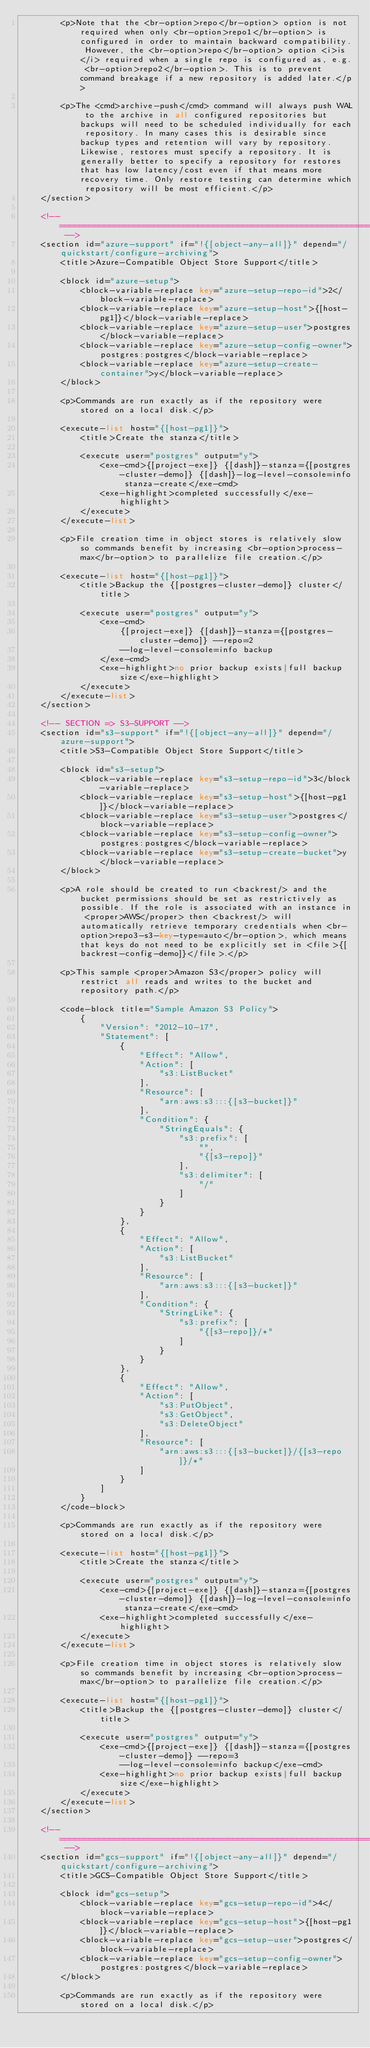Convert code to text. <code><loc_0><loc_0><loc_500><loc_500><_XML_>        <p>Note that the <br-option>repo</br-option> option is not required when only <br-option>repo1</br-option> is configured in order to maintain backward compatibility. However, the <br-option>repo</br-option> option <i>is</i> required when a single repo is configured as, e.g. <br-option>repo2</br-option>. This is to prevent command breakage if a new repository is added later.</p>

        <p>The <cmd>archive-push</cmd> command will always push WAL to the archive in all configured repositories but backups will need to be scheduled individually for each repository. In many cases this is desirable since backup types and retention will vary by repository. Likewise, restores must specify a repository. It is generally better to specify a repository for restores that has low latency/cost even if that means more recovery time. Only restore testing can determine which repository will be most efficient.</p>
    </section>

    <!-- ======================================================================================================================= -->
    <section id="azure-support" if="!{[object-any-all]}" depend="/quickstart/configure-archiving">
        <title>Azure-Compatible Object Store Support</title>

        <block id="azure-setup">
            <block-variable-replace key="azure-setup-repo-id">2</block-variable-replace>
            <block-variable-replace key="azure-setup-host">{[host-pg1]}</block-variable-replace>
            <block-variable-replace key="azure-setup-user">postgres</block-variable-replace>
            <block-variable-replace key="azure-setup-config-owner">postgres:postgres</block-variable-replace>
            <block-variable-replace key="azure-setup-create-container">y</block-variable-replace>
        </block>

        <p>Commands are run exactly as if the repository were stored on a local disk.</p>

        <execute-list host="{[host-pg1]}">
            <title>Create the stanza</title>

            <execute user="postgres" output="y">
                <exe-cmd>{[project-exe]} {[dash]}-stanza={[postgres-cluster-demo]} {[dash]}-log-level-console=info stanza-create</exe-cmd>
                <exe-highlight>completed successfully</exe-highlight>
            </execute>
        </execute-list>

        <p>File creation time in object stores is relatively slow so commands benefit by increasing <br-option>process-max</br-option> to parallelize file creation.</p>

        <execute-list host="{[host-pg1]}">
            <title>Backup the {[postgres-cluster-demo]} cluster</title>

            <execute user="postgres" output="y">
                <exe-cmd>
                    {[project-exe]} {[dash]}-stanza={[postgres-cluster-demo]} --repo=2
                    --log-level-console=info backup
                </exe-cmd>
                <exe-highlight>no prior backup exists|full backup size</exe-highlight>
            </execute>
        </execute-list>
    </section>

    <!-- SECTION => S3-SUPPORT -->
    <section id="s3-support" if="!{[object-any-all]}" depend="/azure-support">
        <title>S3-Compatible Object Store Support</title>

        <block id="s3-setup">
            <block-variable-replace key="s3-setup-repo-id">3</block-variable-replace>
            <block-variable-replace key="s3-setup-host">{[host-pg1]}</block-variable-replace>
            <block-variable-replace key="s3-setup-user">postgres</block-variable-replace>
            <block-variable-replace key="s3-setup-config-owner">postgres:postgres</block-variable-replace>
            <block-variable-replace key="s3-setup-create-bucket">y</block-variable-replace>
        </block>

        <p>A role should be created to run <backrest/> and the bucket permissions should be set as restrictively as possible. If the role is associated with an instance in <proper>AWS</proper> then <backrest/> will automatically retrieve temporary credentials when <br-option>repo3-s3-key-type=auto</br-option>, which means that keys do not need to be explicitly set in <file>{[backrest-config-demo]}</file>.</p>

        <p>This sample <proper>Amazon S3</proper> policy will restrict all reads and writes to the bucket and repository path.</p>

        <code-block title="Sample Amazon S3 Policy">
            {
                "Version": "2012-10-17",
                "Statement": [
                    {
                        "Effect": "Allow",
                        "Action": [
                            "s3:ListBucket"
                        ],
                        "Resource": [
                            "arn:aws:s3:::{[s3-bucket]}"
                        ],
                        "Condition": {
                            "StringEquals": {
                                "s3:prefix": [
                                    "",
                                    "{[s3-repo]}"
                                ],
                                "s3:delimiter": [
                                    "/"
                                ]
                            }
                        }
                    },
                    {
                        "Effect": "Allow",
                        "Action": [
                            "s3:ListBucket"
                        ],
                        "Resource": [
                            "arn:aws:s3:::{[s3-bucket]}"
                        ],
                        "Condition": {
                            "StringLike": {
                                "s3:prefix": [
                                    "{[s3-repo]}/*"
                                ]
                            }
                        }
                    },
                    {
                        "Effect": "Allow",
                        "Action": [
                            "s3:PutObject",
                            "s3:GetObject",
                            "s3:DeleteObject"
                        ],
                        "Resource": [
                            "arn:aws:s3:::{[s3-bucket]}/{[s3-repo]}/*"
                        ]
                    }
                ]
            }
        </code-block>

        <p>Commands are run exactly as if the repository were stored on a local disk.</p>

        <execute-list host="{[host-pg1]}">
            <title>Create the stanza</title>

            <execute user="postgres" output="y">
                <exe-cmd>{[project-exe]} {[dash]}-stanza={[postgres-cluster-demo]} {[dash]}-log-level-console=info stanza-create</exe-cmd>
                <exe-highlight>completed successfully</exe-highlight>
            </execute>
        </execute-list>

        <p>File creation time in object stores is relatively slow so commands benefit by increasing <br-option>process-max</br-option> to parallelize file creation.</p>

        <execute-list host="{[host-pg1]}">
            <title>Backup the {[postgres-cluster-demo]} cluster</title>

            <execute user="postgres" output="y">
                <exe-cmd>{[project-exe]} {[dash]}-stanza={[postgres-cluster-demo]} --repo=3
                    --log-level-console=info backup</exe-cmd>
                <exe-highlight>no prior backup exists|full backup size</exe-highlight>
            </execute>
        </execute-list>
    </section>

    <!-- ======================================================================================================================= -->
    <section id="gcs-support" if="!{[object-any-all]}" depend="/quickstart/configure-archiving">
        <title>GCS-Compatible Object Store Support</title>

        <block id="gcs-setup">
            <block-variable-replace key="gcs-setup-repo-id">4</block-variable-replace>
            <block-variable-replace key="gcs-setup-host">{[host-pg1]}</block-variable-replace>
            <block-variable-replace key="gcs-setup-user">postgres</block-variable-replace>
            <block-variable-replace key="gcs-setup-config-owner">postgres:postgres</block-variable-replace>
        </block>

        <p>Commands are run exactly as if the repository were stored on a local disk.</p>
</code> 